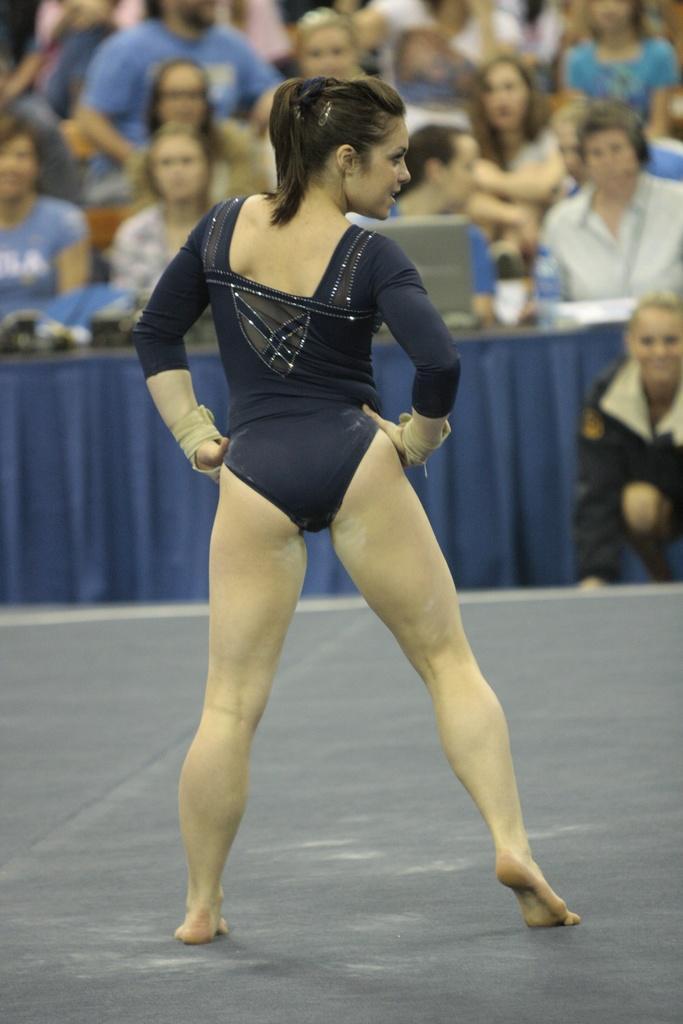Can you describe this image briefly? In this image I can see one person is standing and wearing navy blue color dress. Background I can see few people, laptop and few objects on the table. 